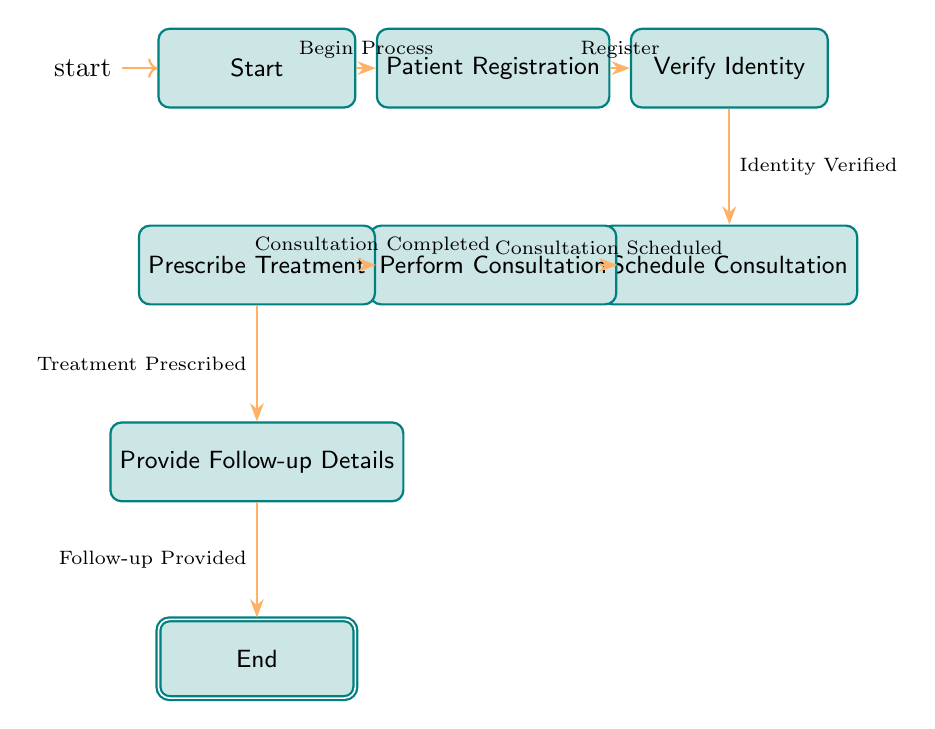What is the starting node of the consultation process? The starting node is explicitly marked as "Start" in the diagram and indicates where the process begins.
Answer: Start How many nodes are there in total? Counting the nodes in the diagram, we find eight distinct nodes, which include "Start", "Patient Registration", "Verify Identity", "Schedule Consultation", "Perform Consultation", "Prescribe Treatment", "Provide Follow-up Details", and "End".
Answer: 8 What transition occurs after "Verify Identity"? Following the "Verify Identity" node, the next transition indicated in the diagram is to "Schedule Consultation". This is shown as an arrow directed towards the "Schedule Consultation" node.
Answer: Schedule Consultation What is the final step in the process? The final step in the process is represented by the node labeled "End", which concludes the entire telemedicine consultation sequence.
Answer: End Which node comes directly after "Perform Consultation"? The diagram indicates that after "Perform Consultation", the subsequent node is "Prescribe Treatment", demonstrating the next action taken in the process flow.
Answer: Prescribe Treatment What is the relationship between "Patient Registration" and "Verify Identity"? The relationship is that "Patient Registration" leads to "Verify Identity" through the transition labeled "Register", indicating that registration must occur before identity verification.
Answer: Register What is the transition associated with providing follow-up details? The transition associated with providing follow-up details is labeled "Follow-up Provided", which indicates that this step successfully follows the prescription of treatment.
Answer: Follow-up Provided How many transitions are there in total? By examining the connections between the nodes, we can count seven transitions that connect the various stages of the consultation process.
Answer: 7 What node signifies the completion of a consultation? The completion of a consultation is marked by the node titled "Perform Consultation", indicating that this is the stage where the consultation is finalized.
Answer: Perform Consultation 